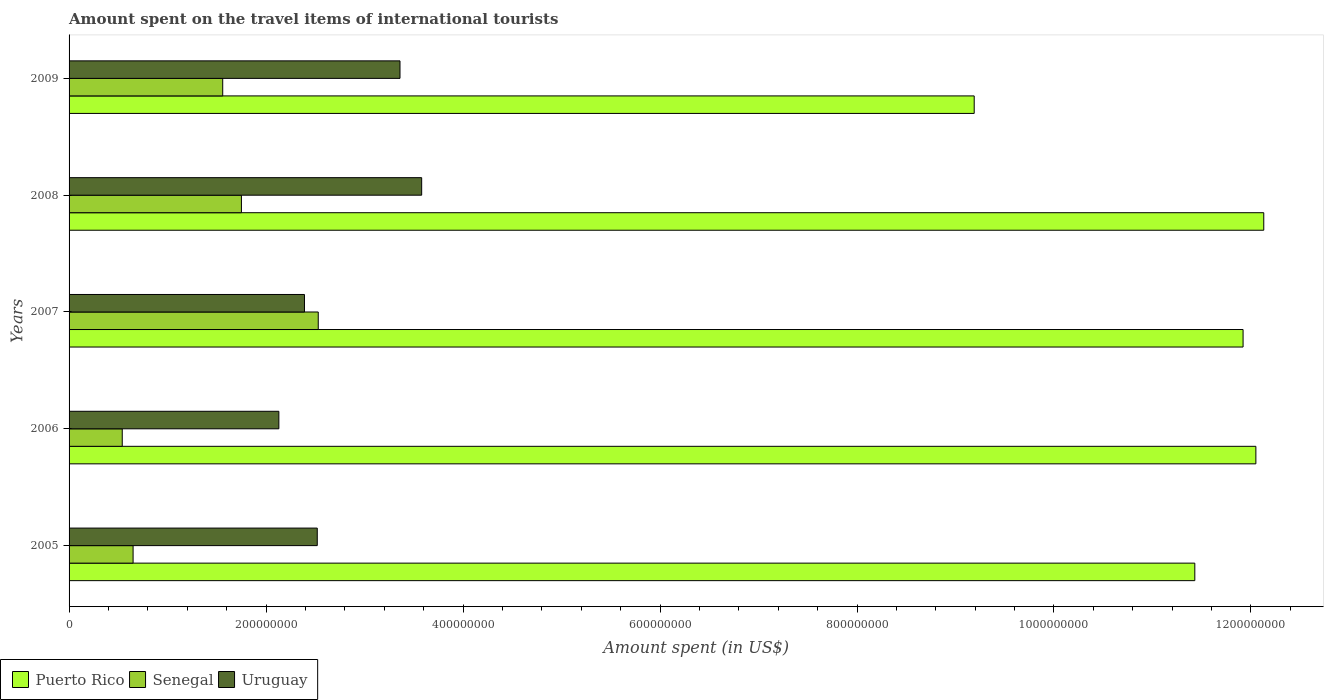How many groups of bars are there?
Make the answer very short. 5. In how many cases, is the number of bars for a given year not equal to the number of legend labels?
Keep it short and to the point. 0. What is the amount spent on the travel items of international tourists in Senegal in 2009?
Your answer should be compact. 1.56e+08. Across all years, what is the maximum amount spent on the travel items of international tourists in Uruguay?
Your response must be concise. 3.58e+08. Across all years, what is the minimum amount spent on the travel items of international tourists in Senegal?
Offer a very short reply. 5.40e+07. In which year was the amount spent on the travel items of international tourists in Senegal maximum?
Your answer should be very brief. 2007. In which year was the amount spent on the travel items of international tourists in Uruguay minimum?
Keep it short and to the point. 2006. What is the total amount spent on the travel items of international tourists in Senegal in the graph?
Keep it short and to the point. 7.03e+08. What is the difference between the amount spent on the travel items of international tourists in Senegal in 2006 and that in 2008?
Your answer should be very brief. -1.21e+08. What is the difference between the amount spent on the travel items of international tourists in Uruguay in 2006 and the amount spent on the travel items of international tourists in Puerto Rico in 2009?
Offer a very short reply. -7.06e+08. What is the average amount spent on the travel items of international tourists in Senegal per year?
Your answer should be very brief. 1.41e+08. In the year 2007, what is the difference between the amount spent on the travel items of international tourists in Uruguay and amount spent on the travel items of international tourists in Puerto Rico?
Your answer should be compact. -9.53e+08. In how many years, is the amount spent on the travel items of international tourists in Puerto Rico greater than 1080000000 US$?
Offer a very short reply. 4. What is the ratio of the amount spent on the travel items of international tourists in Puerto Rico in 2005 to that in 2007?
Make the answer very short. 0.96. What is the difference between the highest and the lowest amount spent on the travel items of international tourists in Puerto Rico?
Offer a terse response. 2.94e+08. In how many years, is the amount spent on the travel items of international tourists in Puerto Rico greater than the average amount spent on the travel items of international tourists in Puerto Rico taken over all years?
Your response must be concise. 4. Is the sum of the amount spent on the travel items of international tourists in Puerto Rico in 2006 and 2007 greater than the maximum amount spent on the travel items of international tourists in Senegal across all years?
Your answer should be very brief. Yes. What does the 1st bar from the top in 2007 represents?
Provide a short and direct response. Uruguay. What does the 2nd bar from the bottom in 2009 represents?
Your answer should be very brief. Senegal. How many bars are there?
Provide a short and direct response. 15. Are the values on the major ticks of X-axis written in scientific E-notation?
Offer a very short reply. No. Does the graph contain any zero values?
Make the answer very short. No. Where does the legend appear in the graph?
Offer a terse response. Bottom left. How many legend labels are there?
Make the answer very short. 3. What is the title of the graph?
Give a very brief answer. Amount spent on the travel items of international tourists. Does "Belarus" appear as one of the legend labels in the graph?
Provide a succinct answer. No. What is the label or title of the X-axis?
Your response must be concise. Amount spent (in US$). What is the Amount spent (in US$) in Puerto Rico in 2005?
Offer a very short reply. 1.14e+09. What is the Amount spent (in US$) of Senegal in 2005?
Ensure brevity in your answer.  6.50e+07. What is the Amount spent (in US$) of Uruguay in 2005?
Give a very brief answer. 2.52e+08. What is the Amount spent (in US$) in Puerto Rico in 2006?
Make the answer very short. 1.20e+09. What is the Amount spent (in US$) of Senegal in 2006?
Offer a terse response. 5.40e+07. What is the Amount spent (in US$) of Uruguay in 2006?
Offer a terse response. 2.13e+08. What is the Amount spent (in US$) in Puerto Rico in 2007?
Offer a terse response. 1.19e+09. What is the Amount spent (in US$) in Senegal in 2007?
Provide a succinct answer. 2.53e+08. What is the Amount spent (in US$) of Uruguay in 2007?
Give a very brief answer. 2.39e+08. What is the Amount spent (in US$) in Puerto Rico in 2008?
Offer a very short reply. 1.21e+09. What is the Amount spent (in US$) of Senegal in 2008?
Your answer should be very brief. 1.75e+08. What is the Amount spent (in US$) in Uruguay in 2008?
Offer a very short reply. 3.58e+08. What is the Amount spent (in US$) in Puerto Rico in 2009?
Offer a very short reply. 9.19e+08. What is the Amount spent (in US$) of Senegal in 2009?
Keep it short and to the point. 1.56e+08. What is the Amount spent (in US$) of Uruguay in 2009?
Your answer should be compact. 3.36e+08. Across all years, what is the maximum Amount spent (in US$) of Puerto Rico?
Keep it short and to the point. 1.21e+09. Across all years, what is the maximum Amount spent (in US$) of Senegal?
Provide a short and direct response. 2.53e+08. Across all years, what is the maximum Amount spent (in US$) of Uruguay?
Give a very brief answer. 3.58e+08. Across all years, what is the minimum Amount spent (in US$) of Puerto Rico?
Offer a very short reply. 9.19e+08. Across all years, what is the minimum Amount spent (in US$) in Senegal?
Offer a terse response. 5.40e+07. Across all years, what is the minimum Amount spent (in US$) of Uruguay?
Offer a very short reply. 2.13e+08. What is the total Amount spent (in US$) of Puerto Rico in the graph?
Your answer should be compact. 5.67e+09. What is the total Amount spent (in US$) in Senegal in the graph?
Offer a very short reply. 7.03e+08. What is the total Amount spent (in US$) of Uruguay in the graph?
Your answer should be compact. 1.40e+09. What is the difference between the Amount spent (in US$) in Puerto Rico in 2005 and that in 2006?
Keep it short and to the point. -6.20e+07. What is the difference between the Amount spent (in US$) in Senegal in 2005 and that in 2006?
Offer a very short reply. 1.10e+07. What is the difference between the Amount spent (in US$) of Uruguay in 2005 and that in 2006?
Make the answer very short. 3.90e+07. What is the difference between the Amount spent (in US$) in Puerto Rico in 2005 and that in 2007?
Ensure brevity in your answer.  -4.90e+07. What is the difference between the Amount spent (in US$) in Senegal in 2005 and that in 2007?
Provide a short and direct response. -1.88e+08. What is the difference between the Amount spent (in US$) of Uruguay in 2005 and that in 2007?
Give a very brief answer. 1.30e+07. What is the difference between the Amount spent (in US$) of Puerto Rico in 2005 and that in 2008?
Your response must be concise. -7.00e+07. What is the difference between the Amount spent (in US$) of Senegal in 2005 and that in 2008?
Provide a succinct answer. -1.10e+08. What is the difference between the Amount spent (in US$) in Uruguay in 2005 and that in 2008?
Provide a short and direct response. -1.06e+08. What is the difference between the Amount spent (in US$) of Puerto Rico in 2005 and that in 2009?
Keep it short and to the point. 2.24e+08. What is the difference between the Amount spent (in US$) of Senegal in 2005 and that in 2009?
Keep it short and to the point. -9.10e+07. What is the difference between the Amount spent (in US$) in Uruguay in 2005 and that in 2009?
Provide a succinct answer. -8.40e+07. What is the difference between the Amount spent (in US$) in Puerto Rico in 2006 and that in 2007?
Your answer should be very brief. 1.30e+07. What is the difference between the Amount spent (in US$) of Senegal in 2006 and that in 2007?
Keep it short and to the point. -1.99e+08. What is the difference between the Amount spent (in US$) of Uruguay in 2006 and that in 2007?
Offer a very short reply. -2.60e+07. What is the difference between the Amount spent (in US$) in Puerto Rico in 2006 and that in 2008?
Provide a short and direct response. -8.00e+06. What is the difference between the Amount spent (in US$) of Senegal in 2006 and that in 2008?
Keep it short and to the point. -1.21e+08. What is the difference between the Amount spent (in US$) of Uruguay in 2006 and that in 2008?
Your response must be concise. -1.45e+08. What is the difference between the Amount spent (in US$) of Puerto Rico in 2006 and that in 2009?
Make the answer very short. 2.86e+08. What is the difference between the Amount spent (in US$) in Senegal in 2006 and that in 2009?
Give a very brief answer. -1.02e+08. What is the difference between the Amount spent (in US$) of Uruguay in 2006 and that in 2009?
Ensure brevity in your answer.  -1.23e+08. What is the difference between the Amount spent (in US$) of Puerto Rico in 2007 and that in 2008?
Your response must be concise. -2.10e+07. What is the difference between the Amount spent (in US$) of Senegal in 2007 and that in 2008?
Provide a short and direct response. 7.80e+07. What is the difference between the Amount spent (in US$) of Uruguay in 2007 and that in 2008?
Your answer should be very brief. -1.19e+08. What is the difference between the Amount spent (in US$) of Puerto Rico in 2007 and that in 2009?
Your answer should be very brief. 2.73e+08. What is the difference between the Amount spent (in US$) in Senegal in 2007 and that in 2009?
Offer a terse response. 9.70e+07. What is the difference between the Amount spent (in US$) of Uruguay in 2007 and that in 2009?
Ensure brevity in your answer.  -9.70e+07. What is the difference between the Amount spent (in US$) in Puerto Rico in 2008 and that in 2009?
Offer a terse response. 2.94e+08. What is the difference between the Amount spent (in US$) in Senegal in 2008 and that in 2009?
Provide a short and direct response. 1.90e+07. What is the difference between the Amount spent (in US$) of Uruguay in 2008 and that in 2009?
Your answer should be very brief. 2.20e+07. What is the difference between the Amount spent (in US$) of Puerto Rico in 2005 and the Amount spent (in US$) of Senegal in 2006?
Make the answer very short. 1.09e+09. What is the difference between the Amount spent (in US$) in Puerto Rico in 2005 and the Amount spent (in US$) in Uruguay in 2006?
Make the answer very short. 9.30e+08. What is the difference between the Amount spent (in US$) of Senegal in 2005 and the Amount spent (in US$) of Uruguay in 2006?
Offer a very short reply. -1.48e+08. What is the difference between the Amount spent (in US$) of Puerto Rico in 2005 and the Amount spent (in US$) of Senegal in 2007?
Keep it short and to the point. 8.90e+08. What is the difference between the Amount spent (in US$) of Puerto Rico in 2005 and the Amount spent (in US$) of Uruguay in 2007?
Offer a terse response. 9.04e+08. What is the difference between the Amount spent (in US$) of Senegal in 2005 and the Amount spent (in US$) of Uruguay in 2007?
Offer a very short reply. -1.74e+08. What is the difference between the Amount spent (in US$) of Puerto Rico in 2005 and the Amount spent (in US$) of Senegal in 2008?
Ensure brevity in your answer.  9.68e+08. What is the difference between the Amount spent (in US$) of Puerto Rico in 2005 and the Amount spent (in US$) of Uruguay in 2008?
Your answer should be very brief. 7.85e+08. What is the difference between the Amount spent (in US$) in Senegal in 2005 and the Amount spent (in US$) in Uruguay in 2008?
Give a very brief answer. -2.93e+08. What is the difference between the Amount spent (in US$) in Puerto Rico in 2005 and the Amount spent (in US$) in Senegal in 2009?
Your response must be concise. 9.87e+08. What is the difference between the Amount spent (in US$) in Puerto Rico in 2005 and the Amount spent (in US$) in Uruguay in 2009?
Offer a very short reply. 8.07e+08. What is the difference between the Amount spent (in US$) in Senegal in 2005 and the Amount spent (in US$) in Uruguay in 2009?
Your answer should be very brief. -2.71e+08. What is the difference between the Amount spent (in US$) of Puerto Rico in 2006 and the Amount spent (in US$) of Senegal in 2007?
Ensure brevity in your answer.  9.52e+08. What is the difference between the Amount spent (in US$) in Puerto Rico in 2006 and the Amount spent (in US$) in Uruguay in 2007?
Offer a very short reply. 9.66e+08. What is the difference between the Amount spent (in US$) of Senegal in 2006 and the Amount spent (in US$) of Uruguay in 2007?
Ensure brevity in your answer.  -1.85e+08. What is the difference between the Amount spent (in US$) of Puerto Rico in 2006 and the Amount spent (in US$) of Senegal in 2008?
Offer a very short reply. 1.03e+09. What is the difference between the Amount spent (in US$) in Puerto Rico in 2006 and the Amount spent (in US$) in Uruguay in 2008?
Your answer should be very brief. 8.47e+08. What is the difference between the Amount spent (in US$) in Senegal in 2006 and the Amount spent (in US$) in Uruguay in 2008?
Offer a very short reply. -3.04e+08. What is the difference between the Amount spent (in US$) of Puerto Rico in 2006 and the Amount spent (in US$) of Senegal in 2009?
Your response must be concise. 1.05e+09. What is the difference between the Amount spent (in US$) of Puerto Rico in 2006 and the Amount spent (in US$) of Uruguay in 2009?
Ensure brevity in your answer.  8.69e+08. What is the difference between the Amount spent (in US$) of Senegal in 2006 and the Amount spent (in US$) of Uruguay in 2009?
Offer a very short reply. -2.82e+08. What is the difference between the Amount spent (in US$) of Puerto Rico in 2007 and the Amount spent (in US$) of Senegal in 2008?
Provide a succinct answer. 1.02e+09. What is the difference between the Amount spent (in US$) of Puerto Rico in 2007 and the Amount spent (in US$) of Uruguay in 2008?
Keep it short and to the point. 8.34e+08. What is the difference between the Amount spent (in US$) of Senegal in 2007 and the Amount spent (in US$) of Uruguay in 2008?
Ensure brevity in your answer.  -1.05e+08. What is the difference between the Amount spent (in US$) of Puerto Rico in 2007 and the Amount spent (in US$) of Senegal in 2009?
Make the answer very short. 1.04e+09. What is the difference between the Amount spent (in US$) in Puerto Rico in 2007 and the Amount spent (in US$) in Uruguay in 2009?
Keep it short and to the point. 8.56e+08. What is the difference between the Amount spent (in US$) of Senegal in 2007 and the Amount spent (in US$) of Uruguay in 2009?
Give a very brief answer. -8.30e+07. What is the difference between the Amount spent (in US$) of Puerto Rico in 2008 and the Amount spent (in US$) of Senegal in 2009?
Keep it short and to the point. 1.06e+09. What is the difference between the Amount spent (in US$) in Puerto Rico in 2008 and the Amount spent (in US$) in Uruguay in 2009?
Provide a succinct answer. 8.77e+08. What is the difference between the Amount spent (in US$) of Senegal in 2008 and the Amount spent (in US$) of Uruguay in 2009?
Provide a short and direct response. -1.61e+08. What is the average Amount spent (in US$) in Puerto Rico per year?
Your answer should be compact. 1.13e+09. What is the average Amount spent (in US$) of Senegal per year?
Keep it short and to the point. 1.41e+08. What is the average Amount spent (in US$) of Uruguay per year?
Make the answer very short. 2.80e+08. In the year 2005, what is the difference between the Amount spent (in US$) of Puerto Rico and Amount spent (in US$) of Senegal?
Offer a terse response. 1.08e+09. In the year 2005, what is the difference between the Amount spent (in US$) in Puerto Rico and Amount spent (in US$) in Uruguay?
Offer a very short reply. 8.91e+08. In the year 2005, what is the difference between the Amount spent (in US$) of Senegal and Amount spent (in US$) of Uruguay?
Your answer should be compact. -1.87e+08. In the year 2006, what is the difference between the Amount spent (in US$) of Puerto Rico and Amount spent (in US$) of Senegal?
Provide a succinct answer. 1.15e+09. In the year 2006, what is the difference between the Amount spent (in US$) in Puerto Rico and Amount spent (in US$) in Uruguay?
Your answer should be compact. 9.92e+08. In the year 2006, what is the difference between the Amount spent (in US$) in Senegal and Amount spent (in US$) in Uruguay?
Provide a short and direct response. -1.59e+08. In the year 2007, what is the difference between the Amount spent (in US$) of Puerto Rico and Amount spent (in US$) of Senegal?
Ensure brevity in your answer.  9.39e+08. In the year 2007, what is the difference between the Amount spent (in US$) in Puerto Rico and Amount spent (in US$) in Uruguay?
Offer a terse response. 9.53e+08. In the year 2007, what is the difference between the Amount spent (in US$) of Senegal and Amount spent (in US$) of Uruguay?
Ensure brevity in your answer.  1.40e+07. In the year 2008, what is the difference between the Amount spent (in US$) of Puerto Rico and Amount spent (in US$) of Senegal?
Make the answer very short. 1.04e+09. In the year 2008, what is the difference between the Amount spent (in US$) of Puerto Rico and Amount spent (in US$) of Uruguay?
Offer a very short reply. 8.55e+08. In the year 2008, what is the difference between the Amount spent (in US$) of Senegal and Amount spent (in US$) of Uruguay?
Your response must be concise. -1.83e+08. In the year 2009, what is the difference between the Amount spent (in US$) of Puerto Rico and Amount spent (in US$) of Senegal?
Offer a very short reply. 7.63e+08. In the year 2009, what is the difference between the Amount spent (in US$) in Puerto Rico and Amount spent (in US$) in Uruguay?
Give a very brief answer. 5.83e+08. In the year 2009, what is the difference between the Amount spent (in US$) of Senegal and Amount spent (in US$) of Uruguay?
Offer a very short reply. -1.80e+08. What is the ratio of the Amount spent (in US$) of Puerto Rico in 2005 to that in 2006?
Provide a succinct answer. 0.95. What is the ratio of the Amount spent (in US$) in Senegal in 2005 to that in 2006?
Provide a short and direct response. 1.2. What is the ratio of the Amount spent (in US$) of Uruguay in 2005 to that in 2006?
Your answer should be very brief. 1.18. What is the ratio of the Amount spent (in US$) in Puerto Rico in 2005 to that in 2007?
Make the answer very short. 0.96. What is the ratio of the Amount spent (in US$) of Senegal in 2005 to that in 2007?
Offer a terse response. 0.26. What is the ratio of the Amount spent (in US$) of Uruguay in 2005 to that in 2007?
Ensure brevity in your answer.  1.05. What is the ratio of the Amount spent (in US$) in Puerto Rico in 2005 to that in 2008?
Ensure brevity in your answer.  0.94. What is the ratio of the Amount spent (in US$) in Senegal in 2005 to that in 2008?
Make the answer very short. 0.37. What is the ratio of the Amount spent (in US$) in Uruguay in 2005 to that in 2008?
Your answer should be compact. 0.7. What is the ratio of the Amount spent (in US$) of Puerto Rico in 2005 to that in 2009?
Give a very brief answer. 1.24. What is the ratio of the Amount spent (in US$) of Senegal in 2005 to that in 2009?
Keep it short and to the point. 0.42. What is the ratio of the Amount spent (in US$) in Uruguay in 2005 to that in 2009?
Keep it short and to the point. 0.75. What is the ratio of the Amount spent (in US$) of Puerto Rico in 2006 to that in 2007?
Provide a short and direct response. 1.01. What is the ratio of the Amount spent (in US$) in Senegal in 2006 to that in 2007?
Your answer should be compact. 0.21. What is the ratio of the Amount spent (in US$) of Uruguay in 2006 to that in 2007?
Make the answer very short. 0.89. What is the ratio of the Amount spent (in US$) of Puerto Rico in 2006 to that in 2008?
Give a very brief answer. 0.99. What is the ratio of the Amount spent (in US$) of Senegal in 2006 to that in 2008?
Make the answer very short. 0.31. What is the ratio of the Amount spent (in US$) of Uruguay in 2006 to that in 2008?
Your answer should be compact. 0.59. What is the ratio of the Amount spent (in US$) in Puerto Rico in 2006 to that in 2009?
Give a very brief answer. 1.31. What is the ratio of the Amount spent (in US$) in Senegal in 2006 to that in 2009?
Offer a terse response. 0.35. What is the ratio of the Amount spent (in US$) of Uruguay in 2006 to that in 2009?
Give a very brief answer. 0.63. What is the ratio of the Amount spent (in US$) in Puerto Rico in 2007 to that in 2008?
Provide a short and direct response. 0.98. What is the ratio of the Amount spent (in US$) in Senegal in 2007 to that in 2008?
Provide a succinct answer. 1.45. What is the ratio of the Amount spent (in US$) of Uruguay in 2007 to that in 2008?
Keep it short and to the point. 0.67. What is the ratio of the Amount spent (in US$) of Puerto Rico in 2007 to that in 2009?
Give a very brief answer. 1.3. What is the ratio of the Amount spent (in US$) of Senegal in 2007 to that in 2009?
Your response must be concise. 1.62. What is the ratio of the Amount spent (in US$) in Uruguay in 2007 to that in 2009?
Offer a terse response. 0.71. What is the ratio of the Amount spent (in US$) in Puerto Rico in 2008 to that in 2009?
Your answer should be compact. 1.32. What is the ratio of the Amount spent (in US$) of Senegal in 2008 to that in 2009?
Provide a succinct answer. 1.12. What is the ratio of the Amount spent (in US$) of Uruguay in 2008 to that in 2009?
Your answer should be compact. 1.07. What is the difference between the highest and the second highest Amount spent (in US$) of Puerto Rico?
Offer a terse response. 8.00e+06. What is the difference between the highest and the second highest Amount spent (in US$) in Senegal?
Your answer should be compact. 7.80e+07. What is the difference between the highest and the second highest Amount spent (in US$) of Uruguay?
Your answer should be compact. 2.20e+07. What is the difference between the highest and the lowest Amount spent (in US$) in Puerto Rico?
Give a very brief answer. 2.94e+08. What is the difference between the highest and the lowest Amount spent (in US$) of Senegal?
Make the answer very short. 1.99e+08. What is the difference between the highest and the lowest Amount spent (in US$) in Uruguay?
Provide a succinct answer. 1.45e+08. 